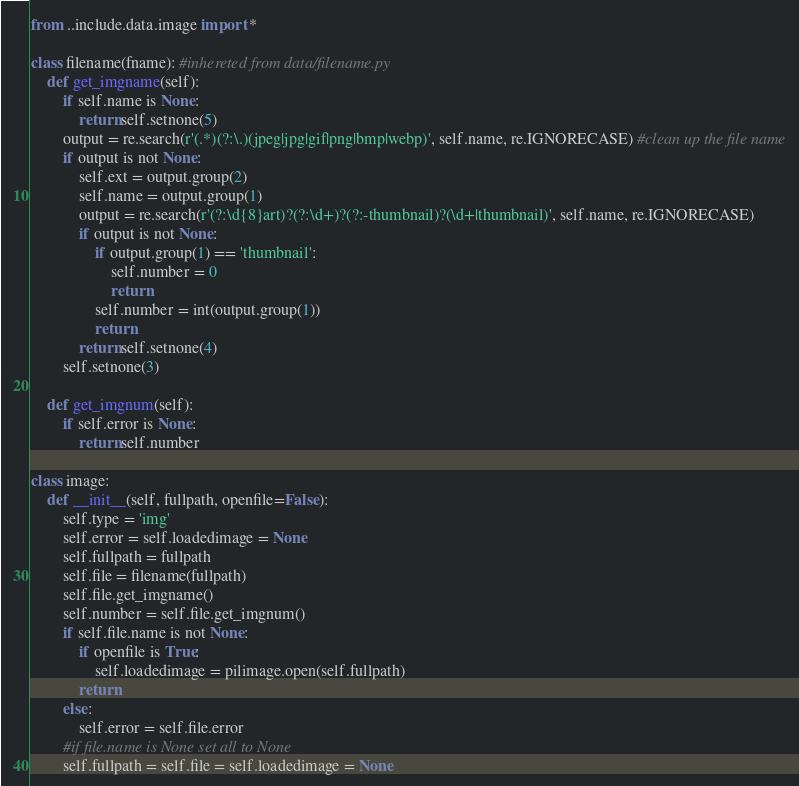<code> <loc_0><loc_0><loc_500><loc_500><_Python_>from ..include.data.image import *

class filename(fname): #inhereted from data/filename.py
	def get_imgname(self):
		if self.name is None:
			return self.setnone(5)
		output = re.search(r'(.*)(?:\.)(jpeg|jpg|gif|png|bmp|webp)', self.name, re.IGNORECASE) #clean up the file name
		if output is not None:
			self.ext = output.group(2)
			self.name = output.group(1)
			output = re.search(r'(?:\d{8}art)?(?:\d+)?(?:-thumbnail)?(\d+|thumbnail)', self.name, re.IGNORECASE)
			if output is not None:
				if output.group(1) == 'thumbnail':
					self.number = 0
					return
				self.number = int(output.group(1))
				return
			return self.setnone(4)
		self.setnone(3)
	
	def get_imgnum(self):
		if self.error is None:
			return self.number

class image:
	def __init__(self, fullpath, openfile=False):
		self.type = 'img'
		self.error = self.loadedimage = None
		self.fullpath = fullpath
		self.file = filename(fullpath)
		self.file.get_imgname()
		self.number = self.file.get_imgnum()
		if self.file.name is not None:
			if openfile is True:
				self.loadedimage = pilimage.open(self.fullpath)
			return
		else:
			self.error = self.file.error
		#if file.name is None set all to None
		self.fullpath = self.file = self.loadedimage = None
</code> 